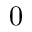<formula> <loc_0><loc_0><loc_500><loc_500>0</formula> 